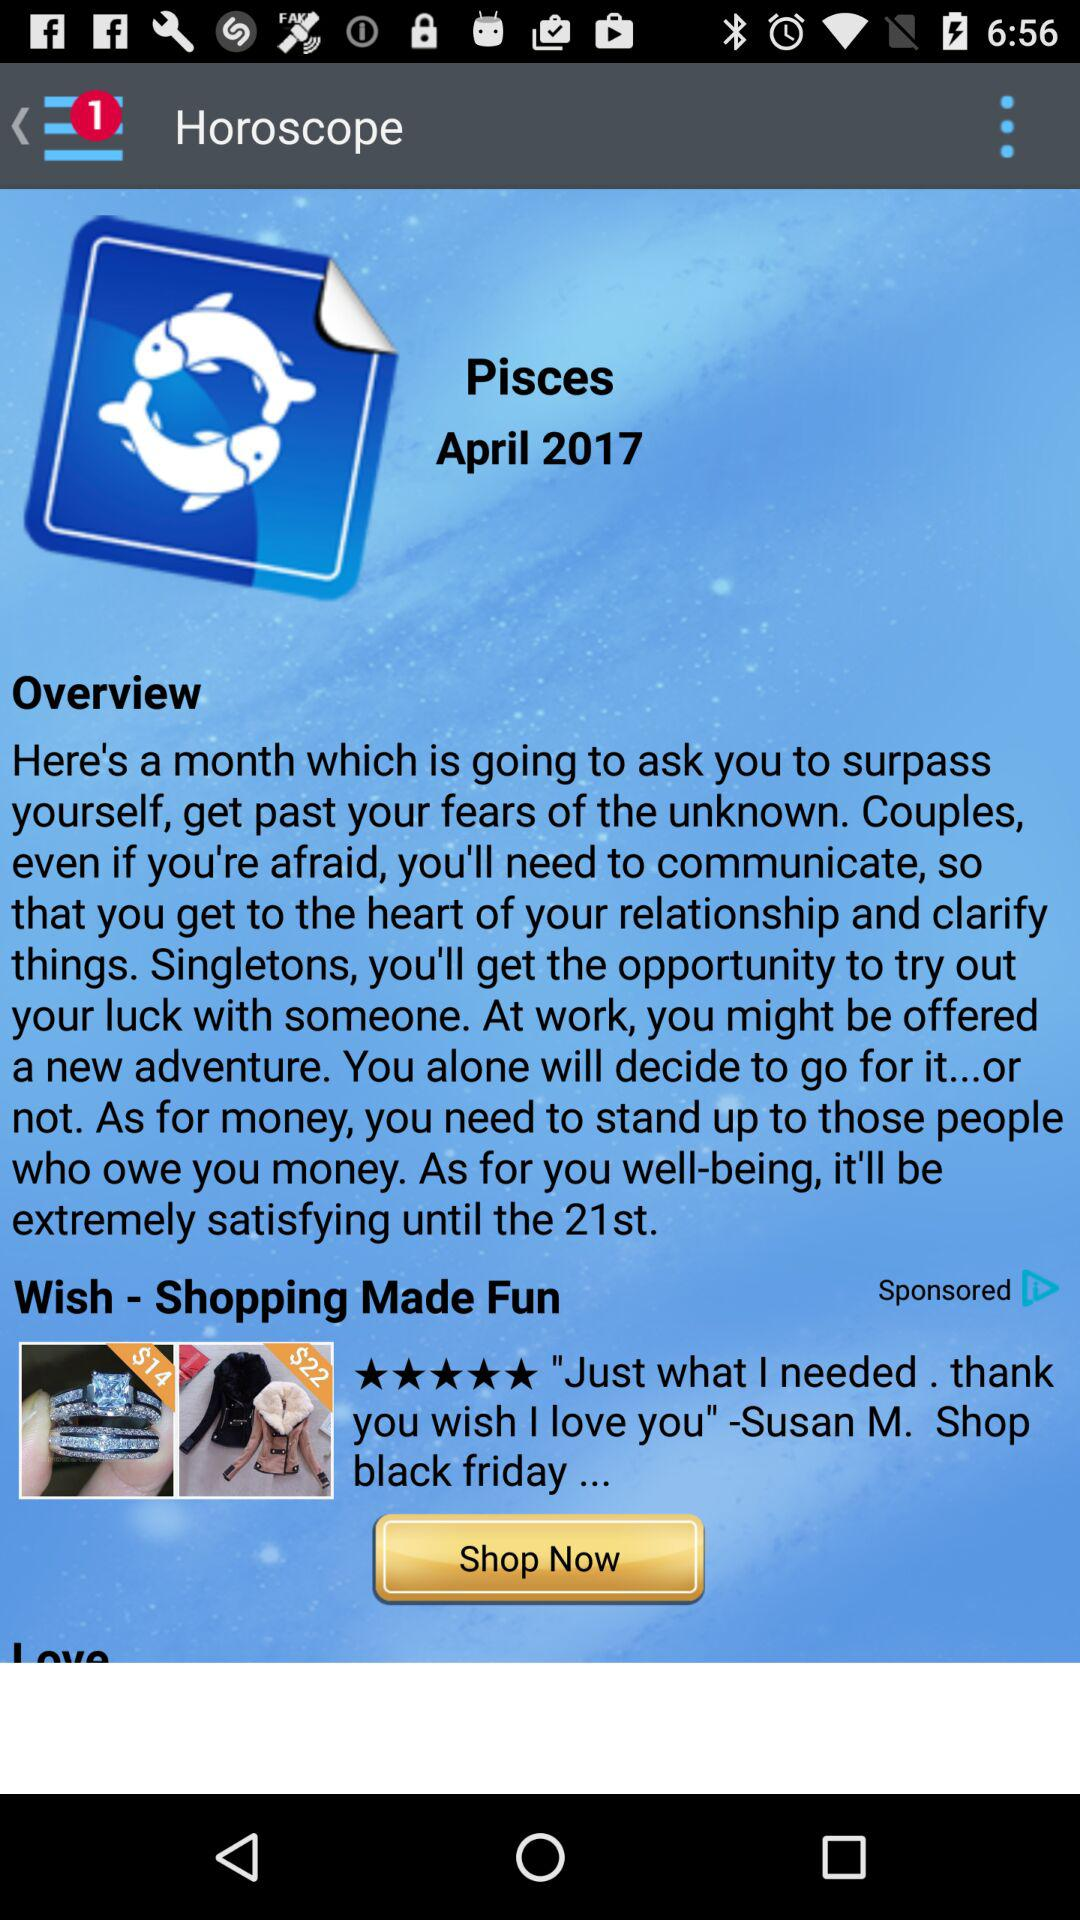How many unread notifications are there in "menu"? There is 1 unread notification. 